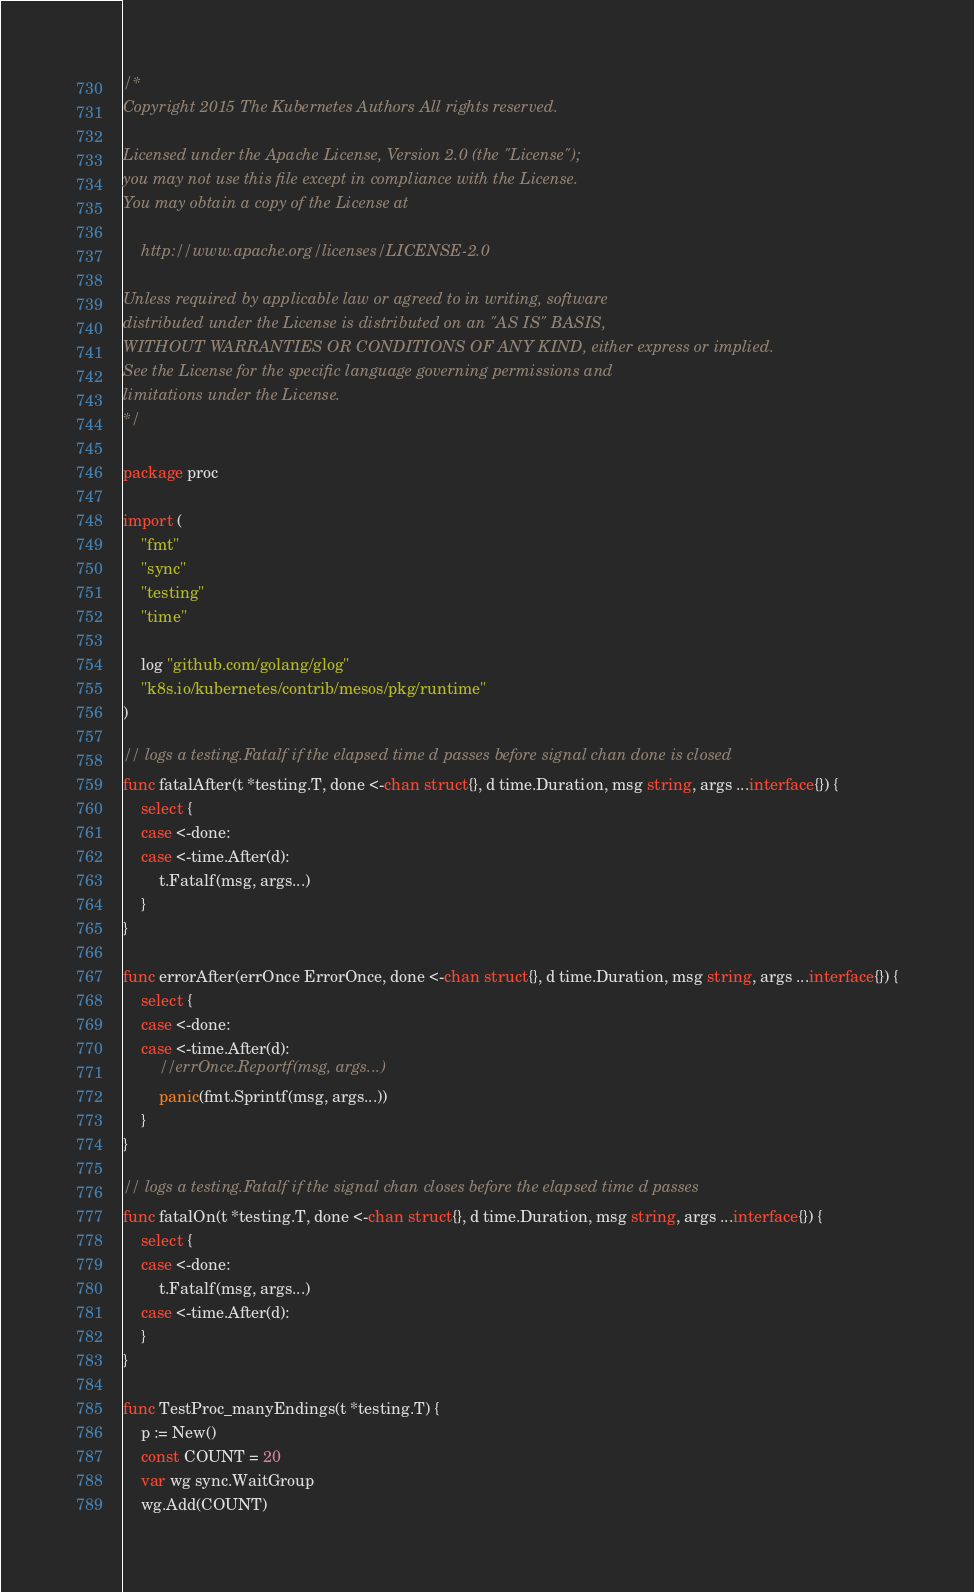<code> <loc_0><loc_0><loc_500><loc_500><_Go_>/*
Copyright 2015 The Kubernetes Authors All rights reserved.

Licensed under the Apache License, Version 2.0 (the "License");
you may not use this file except in compliance with the License.
You may obtain a copy of the License at

    http://www.apache.org/licenses/LICENSE-2.0

Unless required by applicable law or agreed to in writing, software
distributed under the License is distributed on an "AS IS" BASIS,
WITHOUT WARRANTIES OR CONDITIONS OF ANY KIND, either express or implied.
See the License for the specific language governing permissions and
limitations under the License.
*/

package proc

import (
	"fmt"
	"sync"
	"testing"
	"time"

	log "github.com/golang/glog"
	"k8s.io/kubernetes/contrib/mesos/pkg/runtime"
)

// logs a testing.Fatalf if the elapsed time d passes before signal chan done is closed
func fatalAfter(t *testing.T, done <-chan struct{}, d time.Duration, msg string, args ...interface{}) {
	select {
	case <-done:
	case <-time.After(d):
		t.Fatalf(msg, args...)
	}
}

func errorAfter(errOnce ErrorOnce, done <-chan struct{}, d time.Duration, msg string, args ...interface{}) {
	select {
	case <-done:
	case <-time.After(d):
		//errOnce.Reportf(msg, args...)
		panic(fmt.Sprintf(msg, args...))
	}
}

// logs a testing.Fatalf if the signal chan closes before the elapsed time d passes
func fatalOn(t *testing.T, done <-chan struct{}, d time.Duration, msg string, args ...interface{}) {
	select {
	case <-done:
		t.Fatalf(msg, args...)
	case <-time.After(d):
	}
}

func TestProc_manyEndings(t *testing.T) {
	p := New()
	const COUNT = 20
	var wg sync.WaitGroup
	wg.Add(COUNT)</code> 